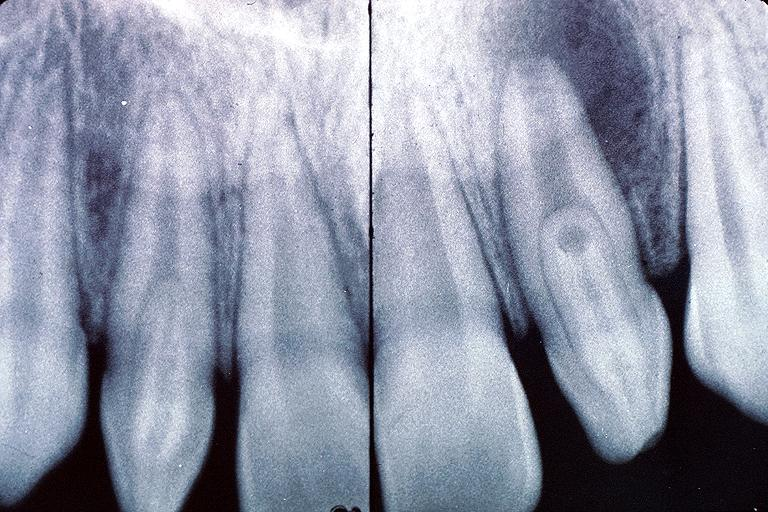does this image show dens invaginatus?
Answer the question using a single word or phrase. Yes 